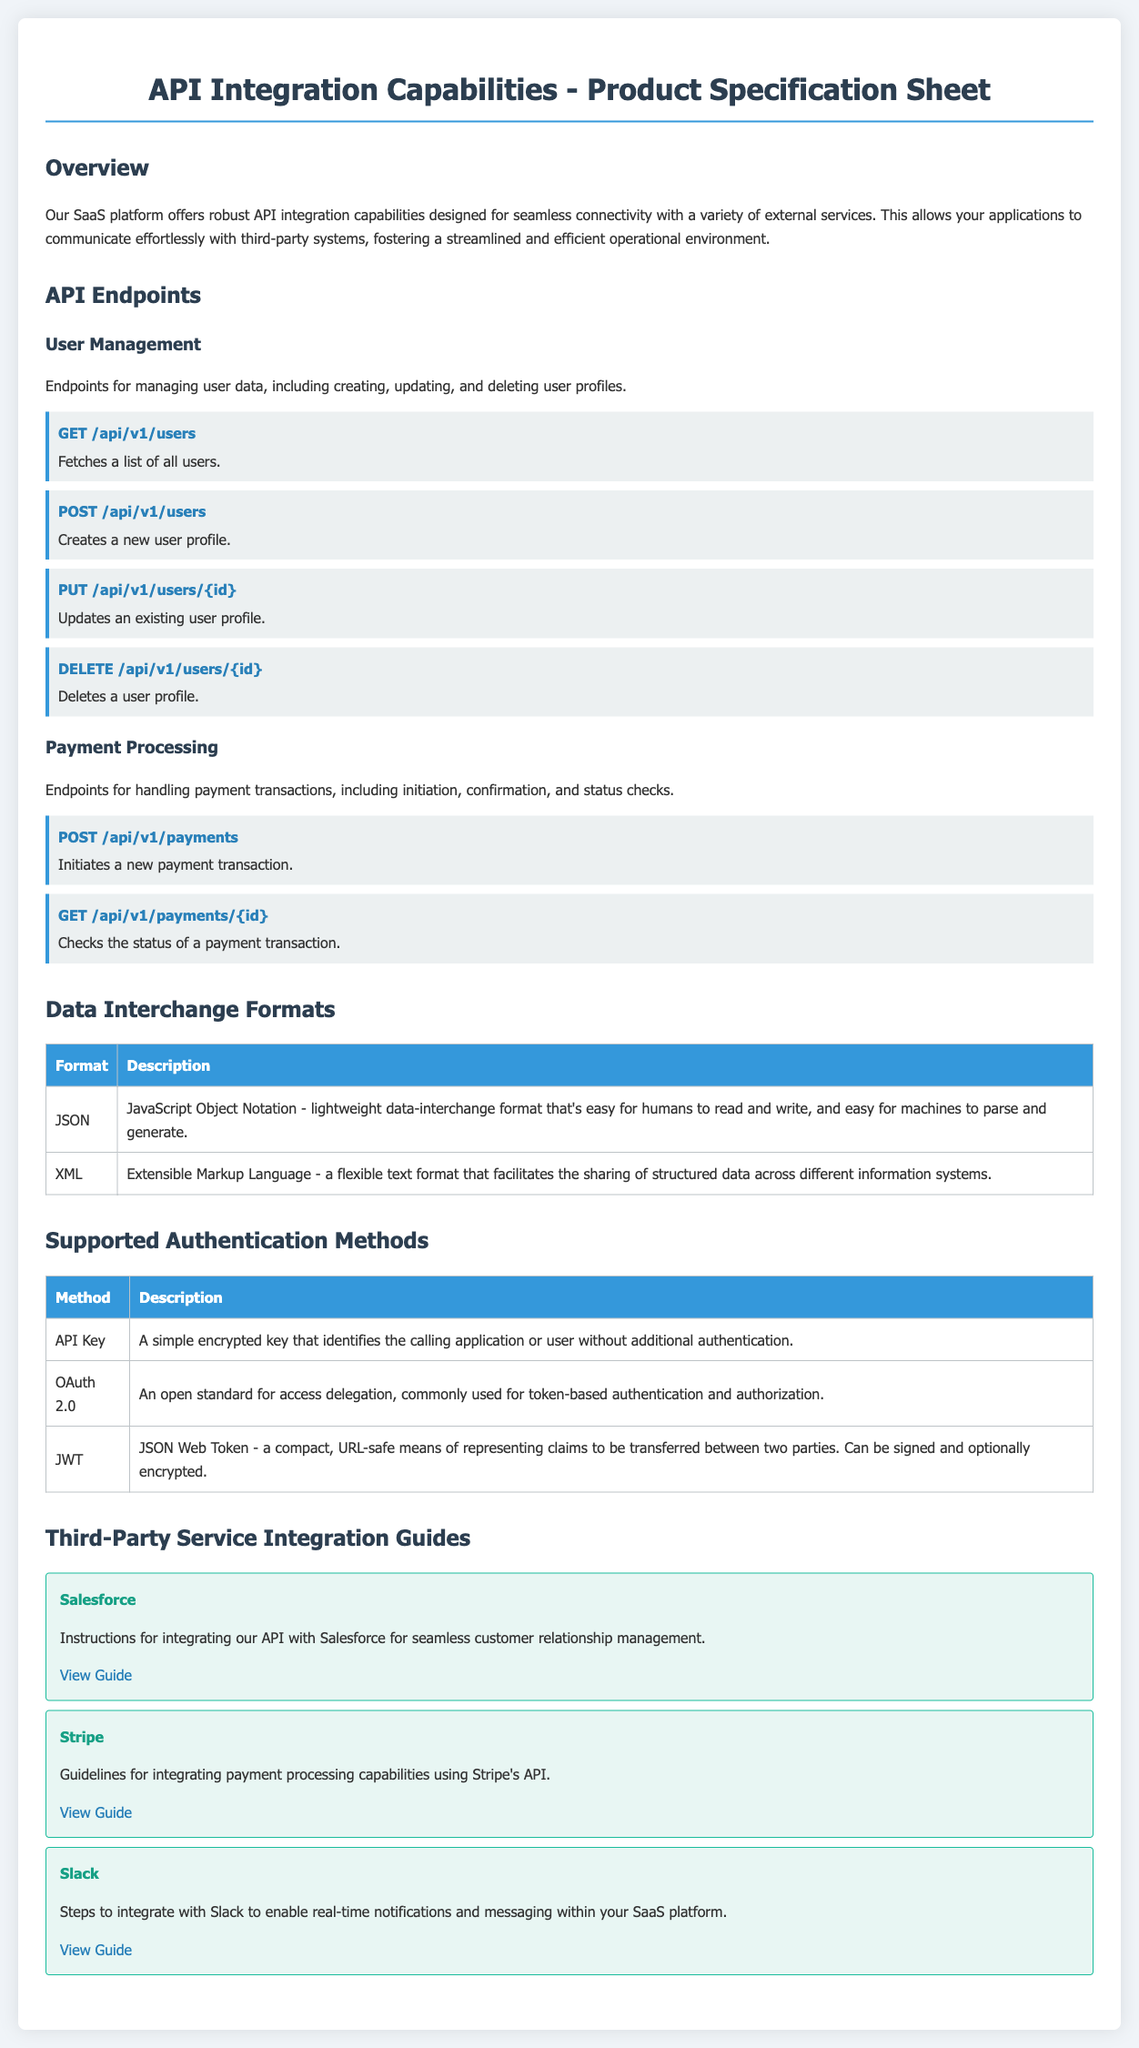What is the main purpose of the API integration capabilities section? The main purpose is to detail the API integration capabilities of the SaaS platform, designed for seamless connectivity with external services.
Answer: Seamless connectivity How many user management endpoints are listed? The document lists four user management endpoints for managing user data.
Answer: Four What data interchange format is described as lightweight and easy to read? JSON is described as a lightweight data interchange format that's easy for humans to read and write.
Answer: JSON Which authentication method uses a simple encrypted key? The authentication method that uses a simple encrypted key is API Key.
Answer: API Key What is the third-party service integrated with for payment processing? The third-party service integrated for payment processing is Stripe.
Answer: Stripe What type of API request is used to fetch a list of all users? The type of API request used is GET.
Answer: GET How many supported authentication methods are mentioned in the document? There are three supported authentication methods mentioned.
Answer: Three What is the URL guide for integrating with Salesforce? The URL guide for integrating with Salesforce is https://developer.salesforce.com/docs/integration_guide.
Answer: https://developer.salesforce.com/docs/integration_guide What does the JWT method stand for? JWT stands for JSON Web Token.
Answer: JSON Web Token 